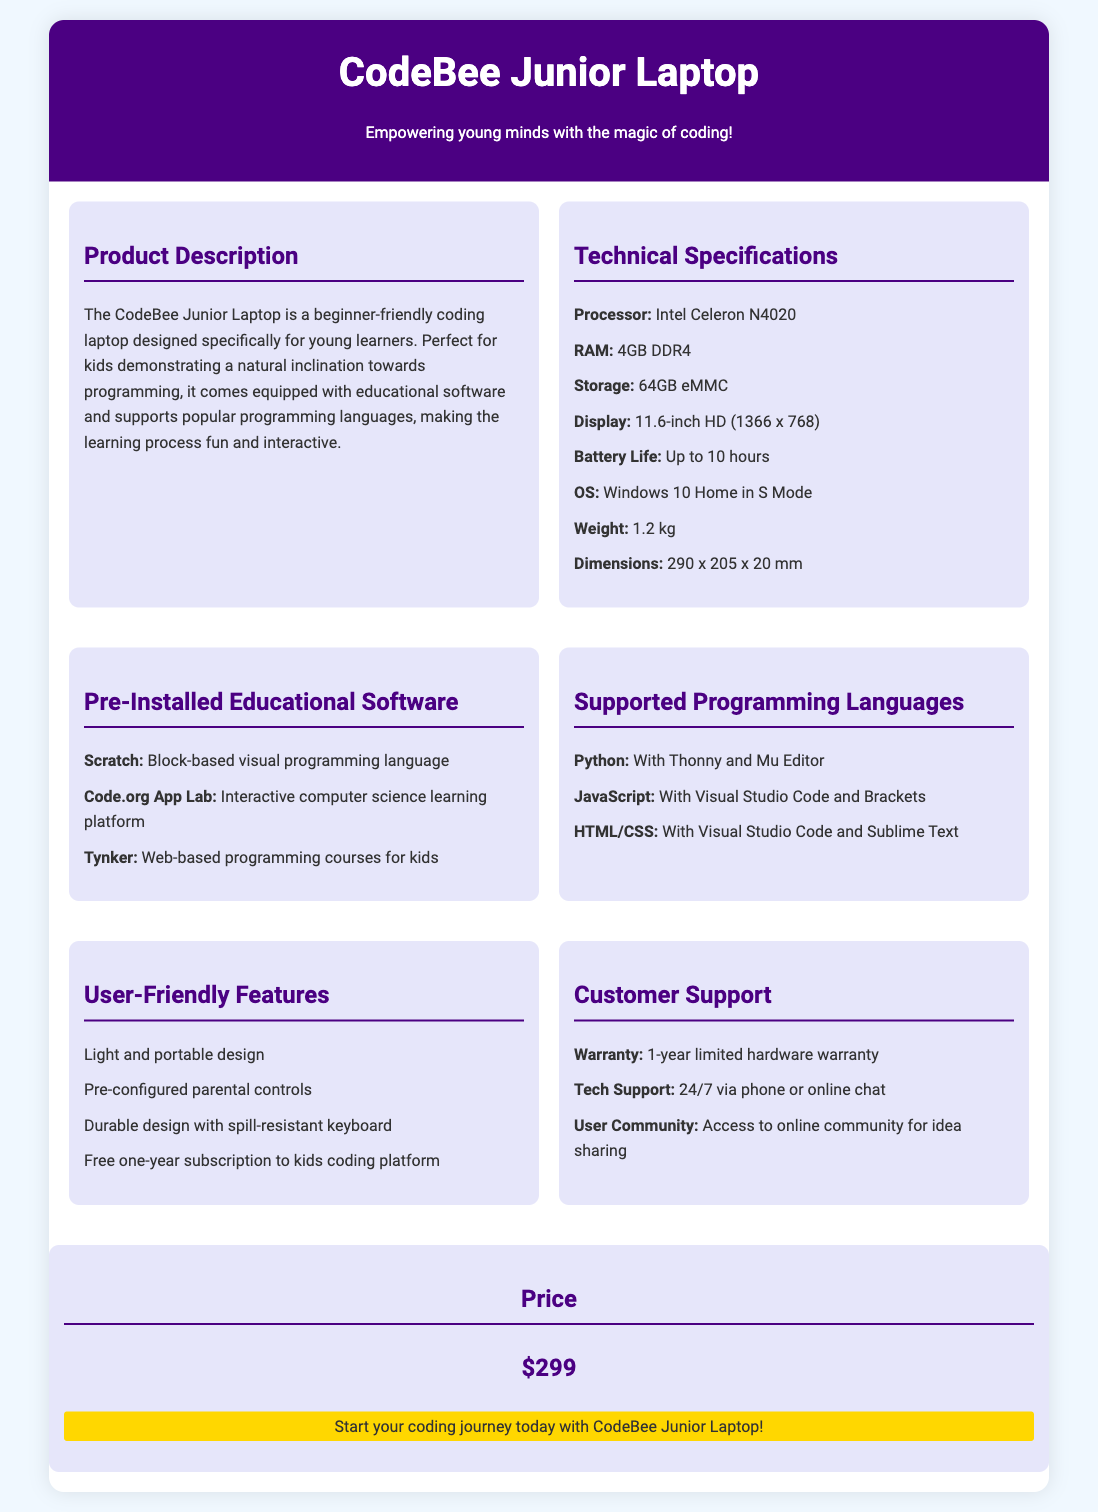what is the processor used in the laptop? The processor used in the laptop is specified in the Technical Specifications section.
Answer: Intel Celeron N4020 how many hours of battery life does it have? Battery life is mentioned in the Technical Specifications section, indicating how long the battery lasts.
Answer: Up to 10 hours what programming languages are supported? Supported programming languages are listed under the Supported Programming Languages section.
Answer: Python, JavaScript, HTML/CSS what is the weight of the laptop? The weight is provided in the Technical Specifications section details.
Answer: 1.2 kg what educational software comes pre-installed? The pre-installed educational software is listed in a dedicated section of the document.
Answer: Scratch, Code.org App Lab, Tynker how long is the warranty? The warranty period is mentioned in the Customer Support section.
Answer: 1-year limited hardware warranty what is the selling price of the laptop? The price is displayed prominently in the document.
Answer: $299 what feature helps in portability? User-friendly features address aspects that make the laptop easy to carry.
Answer: Light and portable design which operating system is installed on the laptop? The operating system is specified in the Technical Specifications section.
Answer: Windows 10 Home in S Mode 